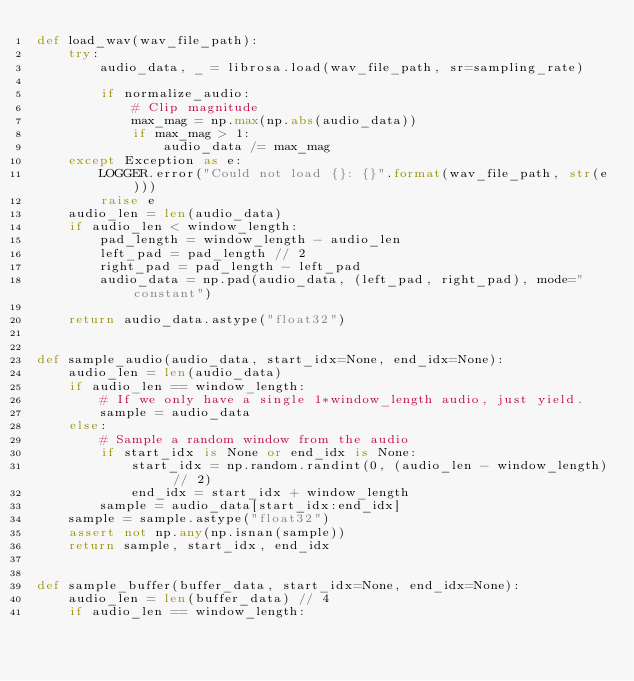Convert code to text. <code><loc_0><loc_0><loc_500><loc_500><_Python_>def load_wav(wav_file_path):
    try:
        audio_data, _ = librosa.load(wav_file_path, sr=sampling_rate)

        if normalize_audio:
            # Clip magnitude
            max_mag = np.max(np.abs(audio_data))
            if max_mag > 1:
                audio_data /= max_mag
    except Exception as e:
        LOGGER.error("Could not load {}: {}".format(wav_file_path, str(e)))
        raise e
    audio_len = len(audio_data)
    if audio_len < window_length:
        pad_length = window_length - audio_len
        left_pad = pad_length // 2
        right_pad = pad_length - left_pad
        audio_data = np.pad(audio_data, (left_pad, right_pad), mode="constant")

    return audio_data.astype("float32")


def sample_audio(audio_data, start_idx=None, end_idx=None):
    audio_len = len(audio_data)
    if audio_len == window_length:
        # If we only have a single 1*window_length audio, just yield.
        sample = audio_data
    else:
        # Sample a random window from the audio
        if start_idx is None or end_idx is None:
            start_idx = np.random.randint(0, (audio_len - window_length) // 2)
            end_idx = start_idx + window_length
        sample = audio_data[start_idx:end_idx]
    sample = sample.astype("float32")
    assert not np.any(np.isnan(sample))
    return sample, start_idx, end_idx


def sample_buffer(buffer_data, start_idx=None, end_idx=None):
    audio_len = len(buffer_data) // 4
    if audio_len == window_length:</code> 